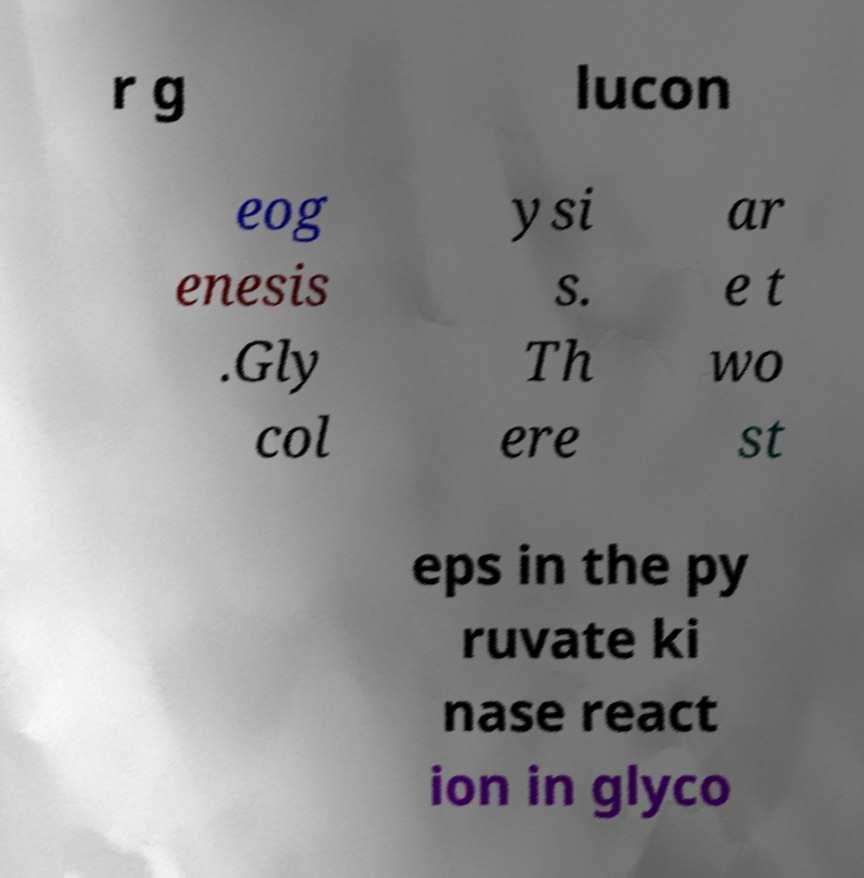Could you assist in decoding the text presented in this image and type it out clearly? r g lucon eog enesis .Gly col ysi s. Th ere ar e t wo st eps in the py ruvate ki nase react ion in glyco 